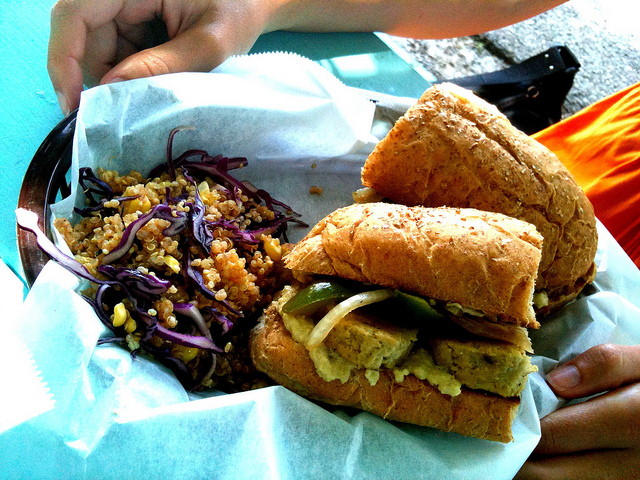What type of food is shown?
A. donuts
B. soup
C. fruit
D. sandwiches
Answer with the option's letter from the given choices directly. D 